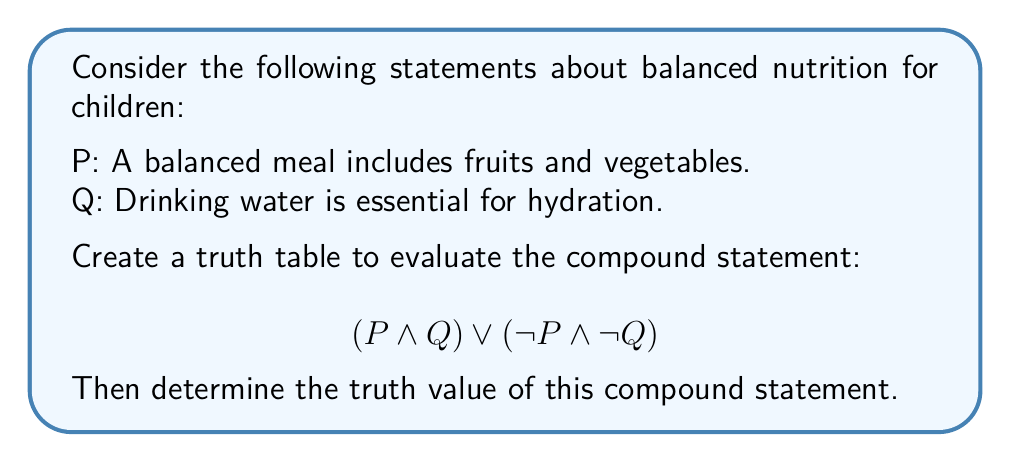Can you solve this math problem? Let's approach this step-by-step:

1) First, we need to create a truth table for the given compound statement. A truth table lists all possible combinations of truth values for the individual statements and their logical combinations.

2) We have two simple statements, P and Q. So our truth table will have 4 rows (2^2 = 4 combinations).

3) Let's create the truth table:

   | P | Q | P ∧ Q | ¬P | ¬Q | ¬P ∧ ¬Q | (P ∧ Q) ∨ (¬P ∧ ¬Q) |
   |---|---|-------|----|----|---------|----------------------|
   | T | T |   T   | F  | F  |    F    |          T           |
   | T | F |   F   | F  | T  |    F    |          F           |
   | F | T |   F   | T  | F  |    F    |          F           |
   | F | F |   F   | T  | T  |    T    |          T           |

4) Let's break down the steps:
   - We evaluate P ∧ Q
   - We find ¬P and ¬Q
   - We evaluate ¬P ∧ ¬Q
   - Finally, we evaluate (P ∧ Q) ∨ (¬P ∧ ¬Q)

5) Looking at the final column, we see that the compound statement is true when both P and Q are true, or when both P and Q are false.

6) In the context of nutrition education for children, this logical structure suggests that a balanced approach to nutrition (where both statements are true) or a complete lack of attention to nutrition (where both statements are false) would make the compound statement true. This could be used to emphasize the importance of consistency in nutrition education.
Answer: The compound statement is true when both P and Q are true, or when both P and Q are false. 